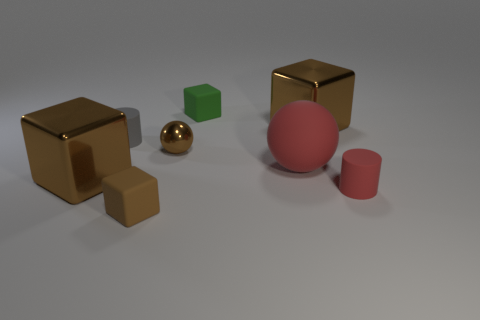Subtract all green cylinders. How many brown cubes are left? 3 Subtract 1 blocks. How many blocks are left? 3 Subtract all red cubes. Subtract all purple spheres. How many cubes are left? 4 Add 1 small red metallic cylinders. How many objects exist? 9 Subtract all cylinders. How many objects are left? 6 Subtract all big brown things. Subtract all balls. How many objects are left? 4 Add 3 brown rubber objects. How many brown rubber objects are left? 4 Add 7 tiny brown metallic balls. How many tiny brown metallic balls exist? 8 Subtract 0 yellow cubes. How many objects are left? 8 